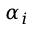<formula> <loc_0><loc_0><loc_500><loc_500>\alpha _ { i }</formula> 